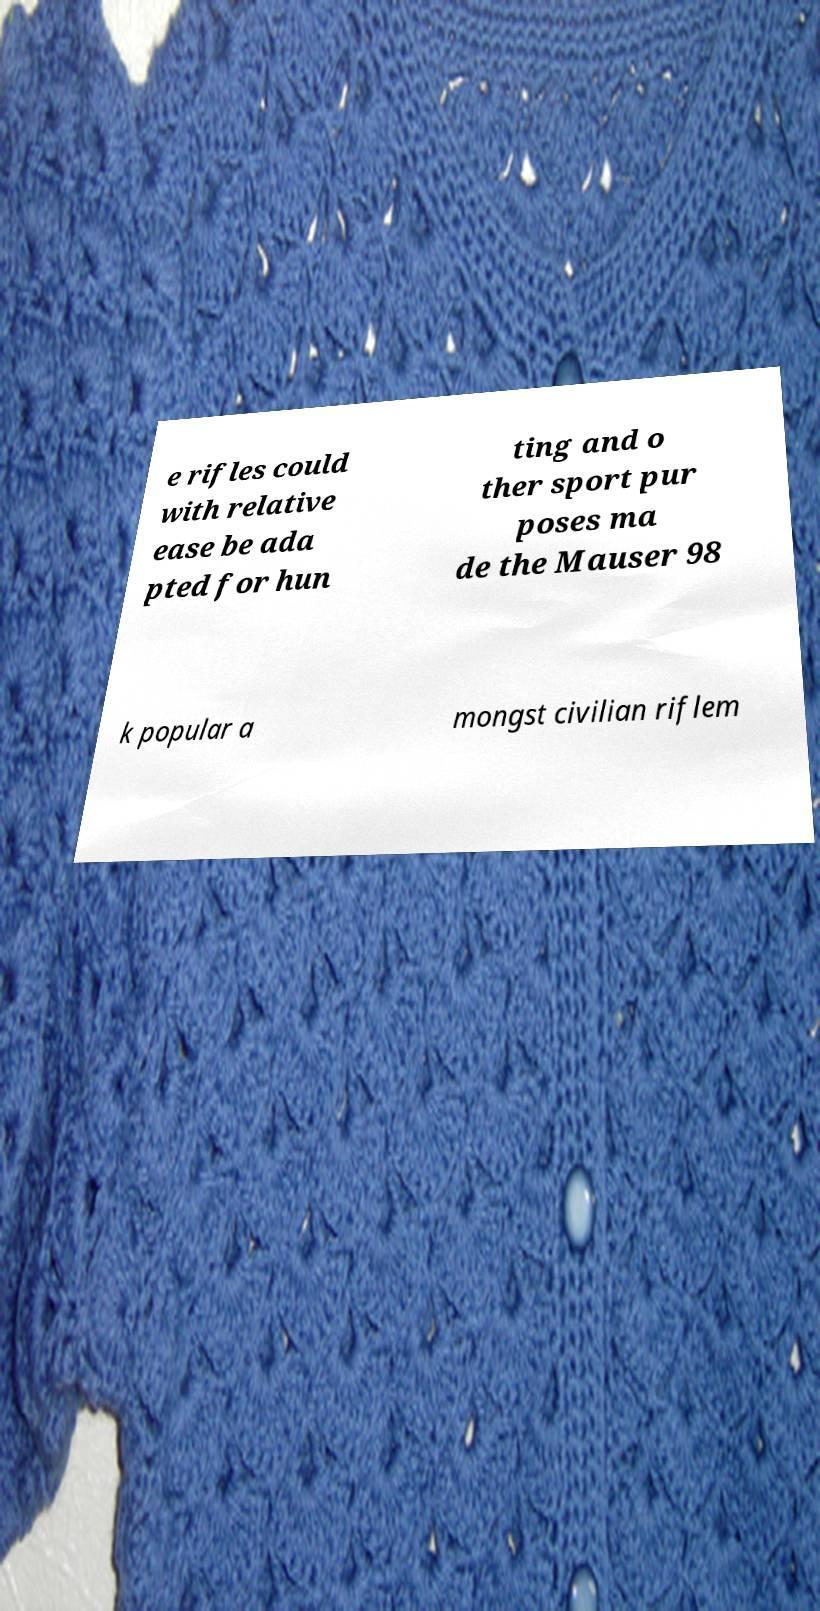I need the written content from this picture converted into text. Can you do that? e rifles could with relative ease be ada pted for hun ting and o ther sport pur poses ma de the Mauser 98 k popular a mongst civilian riflem 